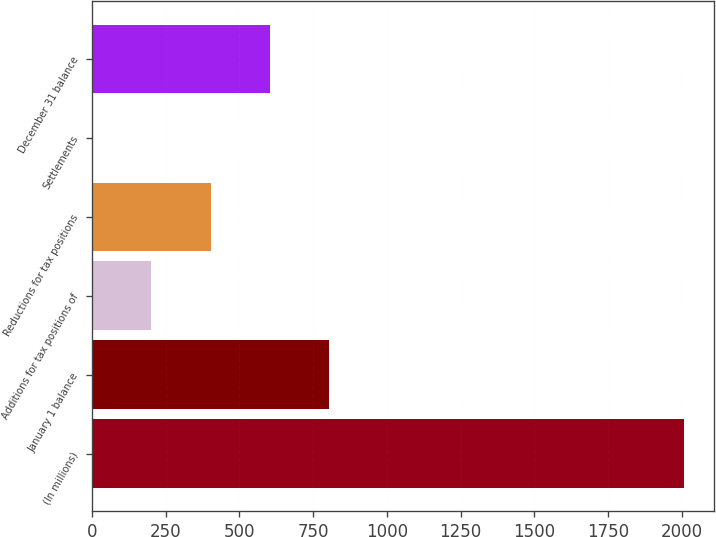Convert chart. <chart><loc_0><loc_0><loc_500><loc_500><bar_chart><fcel>(In millions)<fcel>January 1 balance<fcel>Additions for tax positions of<fcel>Reductions for tax positions<fcel>Settlements<fcel>December 31 balance<nl><fcel>2008<fcel>803.8<fcel>201.7<fcel>402.4<fcel>1<fcel>603.1<nl></chart> 